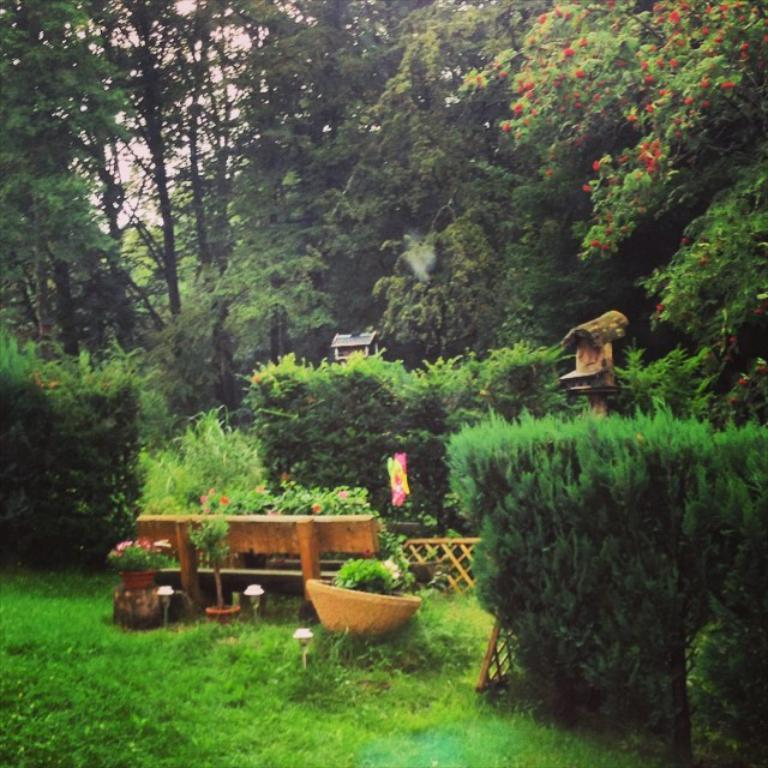What type of vegetation is present in the image? There is grass, plants, and flowers in the image. What type of seating is visible in the image? There is a bench in the image. What can be seen in the background of the image? There are trees and the sky visible in the background of the image. How many daughters are present in the image? There is no mention of a daughter in the image; it features grass, plants, flowers, a bench, trees, and the sky. Can you tell me how many sons are depicted interacting with the flowers in the image? There is no son present in the image; it features grass, plants, flowers, a bench, trees, and the sky. 